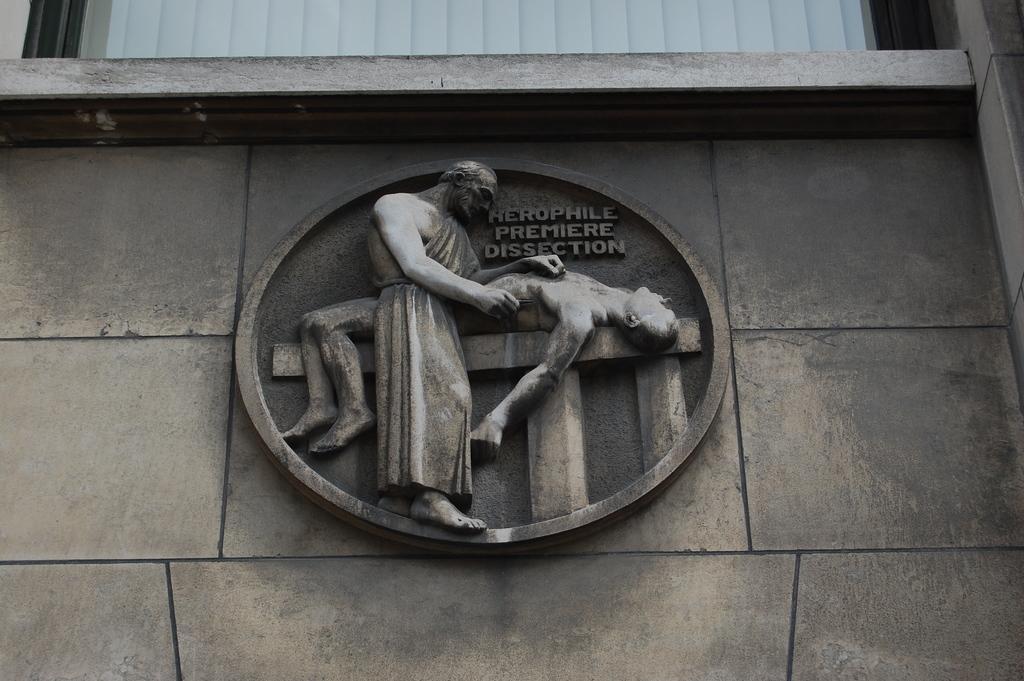How would you summarize this image in a sentence or two? In the center of the image there is a building, wall, white color object, sculptures and a few other objects. And we can see some text on the wall. 